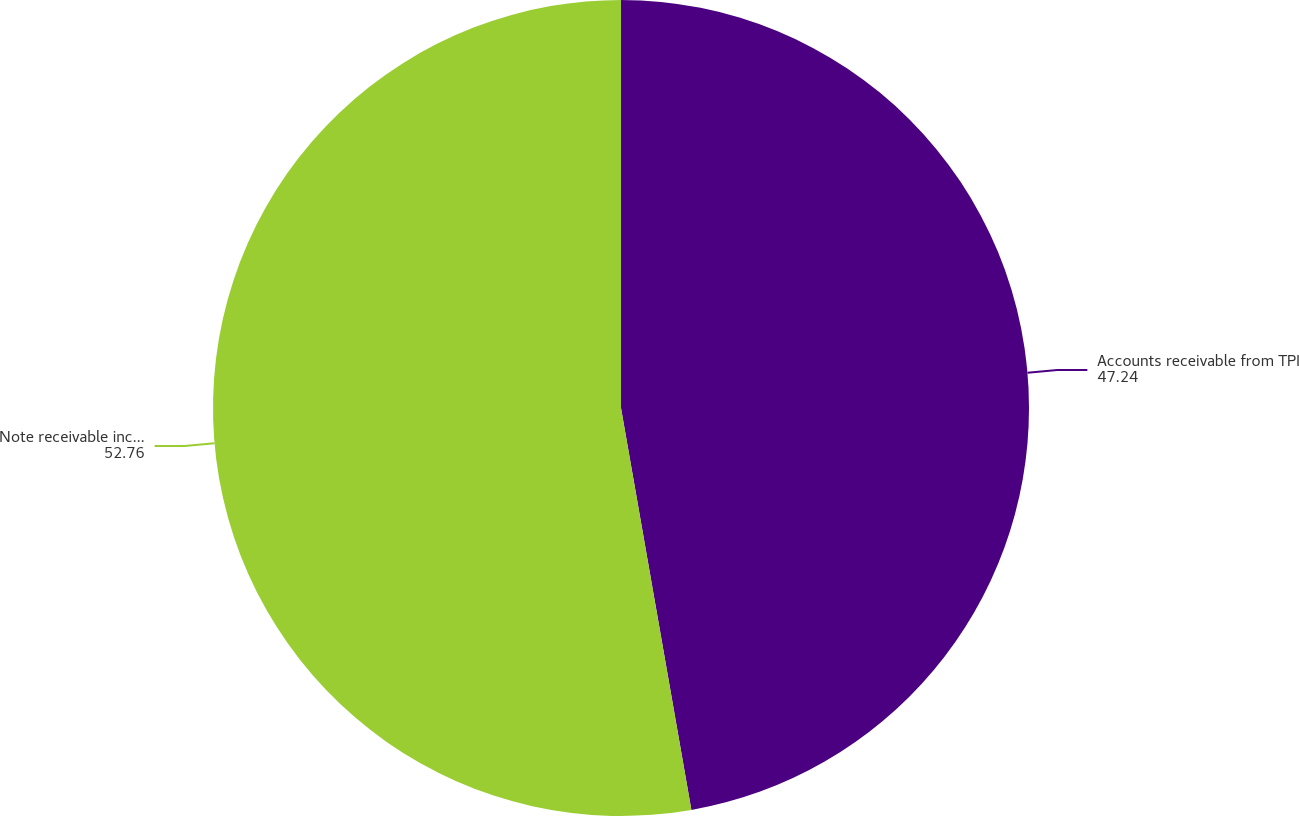Convert chart to OTSL. <chart><loc_0><loc_0><loc_500><loc_500><pie_chart><fcel>Accounts receivable from TPI<fcel>Note receivable including<nl><fcel>47.24%<fcel>52.76%<nl></chart> 